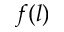Convert formula to latex. <formula><loc_0><loc_0><loc_500><loc_500>f ( l )</formula> 